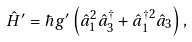Convert formula to latex. <formula><loc_0><loc_0><loc_500><loc_500>\hat { H } ^ { \prime } = \hbar { g } ^ { \prime } \left ( \hat { a } ^ { 2 } _ { 1 } \hat { a } _ { 3 } ^ { \dag } + \hat { a } _ { 1 } ^ { \dag 2 } \hat { a } _ { 3 } \right ) ,</formula> 